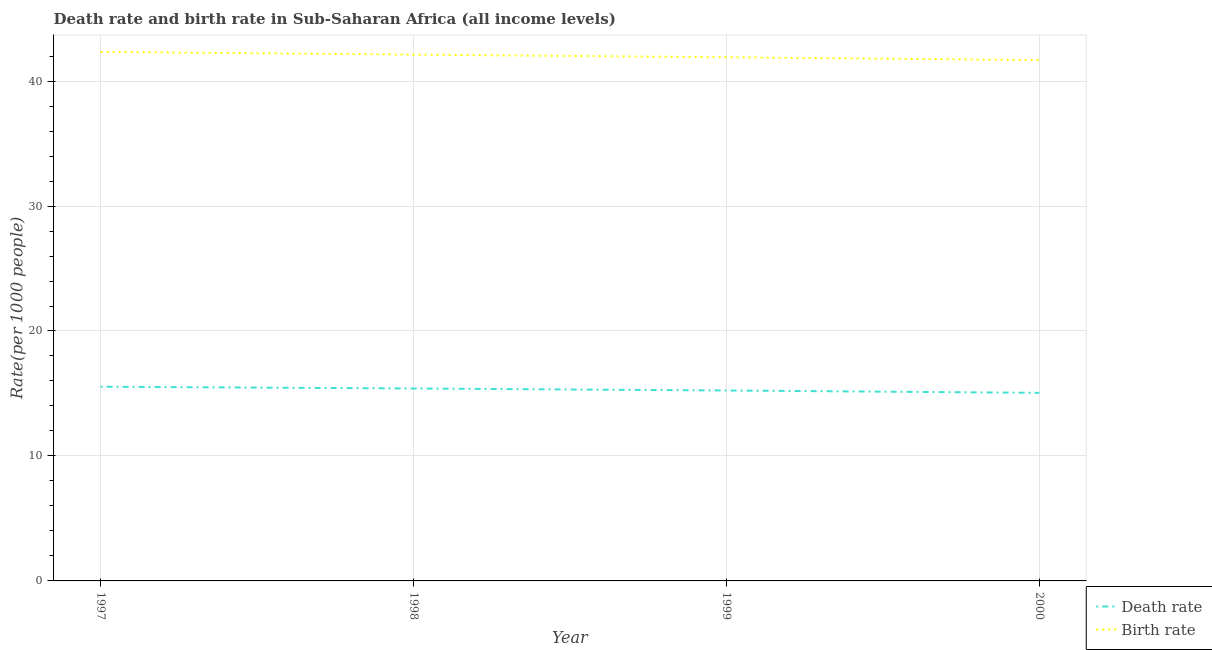Is the number of lines equal to the number of legend labels?
Give a very brief answer. Yes. What is the death rate in 1997?
Give a very brief answer. 15.54. Across all years, what is the maximum death rate?
Your answer should be compact. 15.54. Across all years, what is the minimum death rate?
Keep it short and to the point. 15.05. In which year was the birth rate maximum?
Offer a terse response. 1997. In which year was the birth rate minimum?
Make the answer very short. 2000. What is the total birth rate in the graph?
Your answer should be very brief. 168.04. What is the difference between the birth rate in 1998 and that in 1999?
Provide a succinct answer. 0.21. What is the difference between the death rate in 1999 and the birth rate in 1998?
Give a very brief answer. -26.88. What is the average death rate per year?
Provide a short and direct response. 15.31. In the year 1998, what is the difference between the birth rate and death rate?
Make the answer very short. 26.72. In how many years, is the death rate greater than 6?
Your answer should be very brief. 4. What is the ratio of the death rate in 1999 to that in 2000?
Your answer should be compact. 1.01. Is the difference between the birth rate in 1997 and 1999 greater than the difference between the death rate in 1997 and 1999?
Ensure brevity in your answer.  Yes. What is the difference between the highest and the second highest birth rate?
Provide a short and direct response. 0.21. What is the difference between the highest and the lowest birth rate?
Your answer should be very brief. 0.65. Is the death rate strictly greater than the birth rate over the years?
Offer a terse response. No. Is the birth rate strictly less than the death rate over the years?
Keep it short and to the point. No. What is the difference between two consecutive major ticks on the Y-axis?
Offer a terse response. 10. Where does the legend appear in the graph?
Your answer should be very brief. Bottom right. What is the title of the graph?
Ensure brevity in your answer.  Death rate and birth rate in Sub-Saharan Africa (all income levels). What is the label or title of the Y-axis?
Make the answer very short. Rate(per 1000 people). What is the Rate(per 1000 people) in Death rate in 1997?
Ensure brevity in your answer.  15.54. What is the Rate(per 1000 people) of Birth rate in 1997?
Offer a terse response. 42.33. What is the Rate(per 1000 people) of Death rate in 1998?
Provide a short and direct response. 15.4. What is the Rate(per 1000 people) in Birth rate in 1998?
Offer a very short reply. 42.12. What is the Rate(per 1000 people) of Death rate in 1999?
Provide a short and direct response. 15.24. What is the Rate(per 1000 people) of Birth rate in 1999?
Keep it short and to the point. 41.9. What is the Rate(per 1000 people) in Death rate in 2000?
Make the answer very short. 15.05. What is the Rate(per 1000 people) in Birth rate in 2000?
Give a very brief answer. 41.68. Across all years, what is the maximum Rate(per 1000 people) of Death rate?
Your answer should be compact. 15.54. Across all years, what is the maximum Rate(per 1000 people) in Birth rate?
Provide a succinct answer. 42.33. Across all years, what is the minimum Rate(per 1000 people) of Death rate?
Provide a short and direct response. 15.05. Across all years, what is the minimum Rate(per 1000 people) of Birth rate?
Provide a short and direct response. 41.68. What is the total Rate(per 1000 people) of Death rate in the graph?
Make the answer very short. 61.23. What is the total Rate(per 1000 people) in Birth rate in the graph?
Keep it short and to the point. 168.04. What is the difference between the Rate(per 1000 people) of Death rate in 1997 and that in 1998?
Give a very brief answer. 0.14. What is the difference between the Rate(per 1000 people) in Birth rate in 1997 and that in 1998?
Your answer should be compact. 0.21. What is the difference between the Rate(per 1000 people) of Death rate in 1997 and that in 1999?
Make the answer very short. 0.3. What is the difference between the Rate(per 1000 people) in Birth rate in 1997 and that in 1999?
Your answer should be very brief. 0.43. What is the difference between the Rate(per 1000 people) of Death rate in 1997 and that in 2000?
Offer a very short reply. 0.49. What is the difference between the Rate(per 1000 people) in Birth rate in 1997 and that in 2000?
Offer a very short reply. 0.65. What is the difference between the Rate(per 1000 people) in Death rate in 1998 and that in 1999?
Offer a very short reply. 0.16. What is the difference between the Rate(per 1000 people) of Birth rate in 1998 and that in 1999?
Your response must be concise. 0.21. What is the difference between the Rate(per 1000 people) in Death rate in 1998 and that in 2000?
Your response must be concise. 0.35. What is the difference between the Rate(per 1000 people) of Birth rate in 1998 and that in 2000?
Make the answer very short. 0.44. What is the difference between the Rate(per 1000 people) of Death rate in 1999 and that in 2000?
Your answer should be very brief. 0.19. What is the difference between the Rate(per 1000 people) in Birth rate in 1999 and that in 2000?
Offer a terse response. 0.22. What is the difference between the Rate(per 1000 people) in Death rate in 1997 and the Rate(per 1000 people) in Birth rate in 1998?
Offer a very short reply. -26.58. What is the difference between the Rate(per 1000 people) of Death rate in 1997 and the Rate(per 1000 people) of Birth rate in 1999?
Provide a short and direct response. -26.36. What is the difference between the Rate(per 1000 people) of Death rate in 1997 and the Rate(per 1000 people) of Birth rate in 2000?
Offer a very short reply. -26.14. What is the difference between the Rate(per 1000 people) of Death rate in 1998 and the Rate(per 1000 people) of Birth rate in 1999?
Offer a terse response. -26.5. What is the difference between the Rate(per 1000 people) in Death rate in 1998 and the Rate(per 1000 people) in Birth rate in 2000?
Offer a terse response. -26.28. What is the difference between the Rate(per 1000 people) in Death rate in 1999 and the Rate(per 1000 people) in Birth rate in 2000?
Offer a very short reply. -26.44. What is the average Rate(per 1000 people) in Death rate per year?
Your answer should be very brief. 15.31. What is the average Rate(per 1000 people) of Birth rate per year?
Ensure brevity in your answer.  42.01. In the year 1997, what is the difference between the Rate(per 1000 people) in Death rate and Rate(per 1000 people) in Birth rate?
Provide a succinct answer. -26.79. In the year 1998, what is the difference between the Rate(per 1000 people) in Death rate and Rate(per 1000 people) in Birth rate?
Offer a very short reply. -26.72. In the year 1999, what is the difference between the Rate(per 1000 people) in Death rate and Rate(per 1000 people) in Birth rate?
Offer a very short reply. -26.66. In the year 2000, what is the difference between the Rate(per 1000 people) of Death rate and Rate(per 1000 people) of Birth rate?
Ensure brevity in your answer.  -26.63. What is the ratio of the Rate(per 1000 people) of Death rate in 1997 to that in 1998?
Offer a very short reply. 1.01. What is the ratio of the Rate(per 1000 people) of Death rate in 1997 to that in 1999?
Make the answer very short. 1.02. What is the ratio of the Rate(per 1000 people) in Birth rate in 1997 to that in 1999?
Offer a terse response. 1.01. What is the ratio of the Rate(per 1000 people) of Death rate in 1997 to that in 2000?
Your answer should be compact. 1.03. What is the ratio of the Rate(per 1000 people) in Birth rate in 1997 to that in 2000?
Your answer should be compact. 1.02. What is the ratio of the Rate(per 1000 people) of Death rate in 1998 to that in 1999?
Your answer should be compact. 1.01. What is the ratio of the Rate(per 1000 people) of Death rate in 1998 to that in 2000?
Make the answer very short. 1.02. What is the ratio of the Rate(per 1000 people) of Birth rate in 1998 to that in 2000?
Ensure brevity in your answer.  1.01. What is the ratio of the Rate(per 1000 people) in Death rate in 1999 to that in 2000?
Keep it short and to the point. 1.01. What is the ratio of the Rate(per 1000 people) in Birth rate in 1999 to that in 2000?
Provide a succinct answer. 1.01. What is the difference between the highest and the second highest Rate(per 1000 people) of Death rate?
Keep it short and to the point. 0.14. What is the difference between the highest and the second highest Rate(per 1000 people) in Birth rate?
Give a very brief answer. 0.21. What is the difference between the highest and the lowest Rate(per 1000 people) of Death rate?
Ensure brevity in your answer.  0.49. What is the difference between the highest and the lowest Rate(per 1000 people) of Birth rate?
Keep it short and to the point. 0.65. 